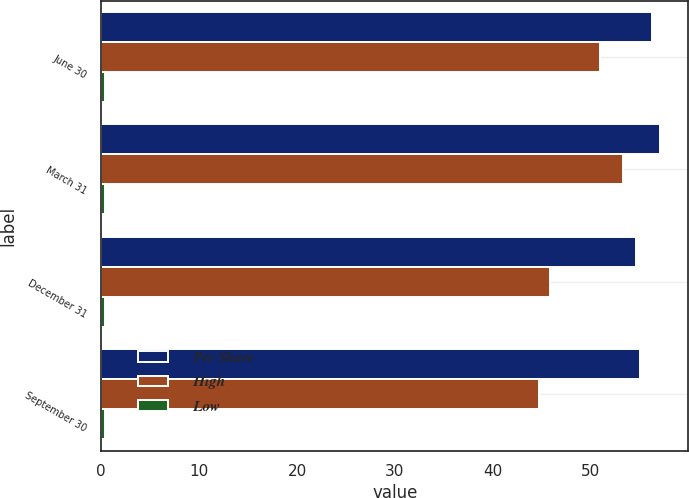Convert chart. <chart><loc_0><loc_0><loc_500><loc_500><stacked_bar_chart><ecel><fcel>June 30<fcel>March 31<fcel>December 31<fcel>September 30<nl><fcel>Per Share<fcel>56.19<fcel>57.1<fcel>54.62<fcel>55.02<nl><fcel>High<fcel>50.89<fcel>53.31<fcel>45.85<fcel>44.72<nl><fcel>Low<fcel>0.4<fcel>0.4<fcel>0.4<fcel>0.36<nl></chart> 